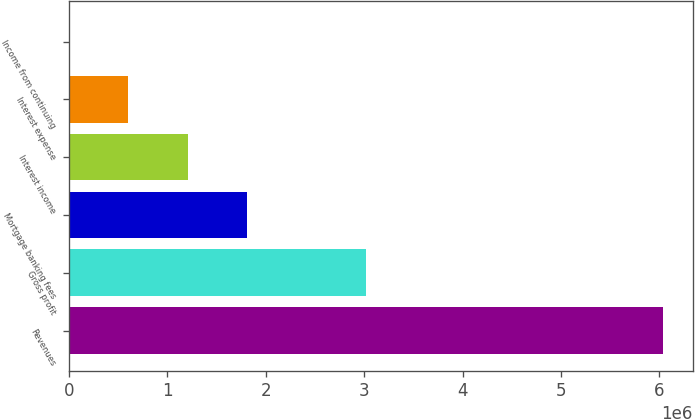Convert chart. <chart><loc_0><loc_0><loc_500><loc_500><bar_chart><fcel>Revenues<fcel>Gross profit<fcel>Mortgage banking fees<fcel>Interest income<fcel>Interest expense<fcel>Income from continuing<nl><fcel>6.03624e+06<fcel>3.01816e+06<fcel>1.81093e+06<fcel>1.20732e+06<fcel>603703<fcel>88.05<nl></chart> 